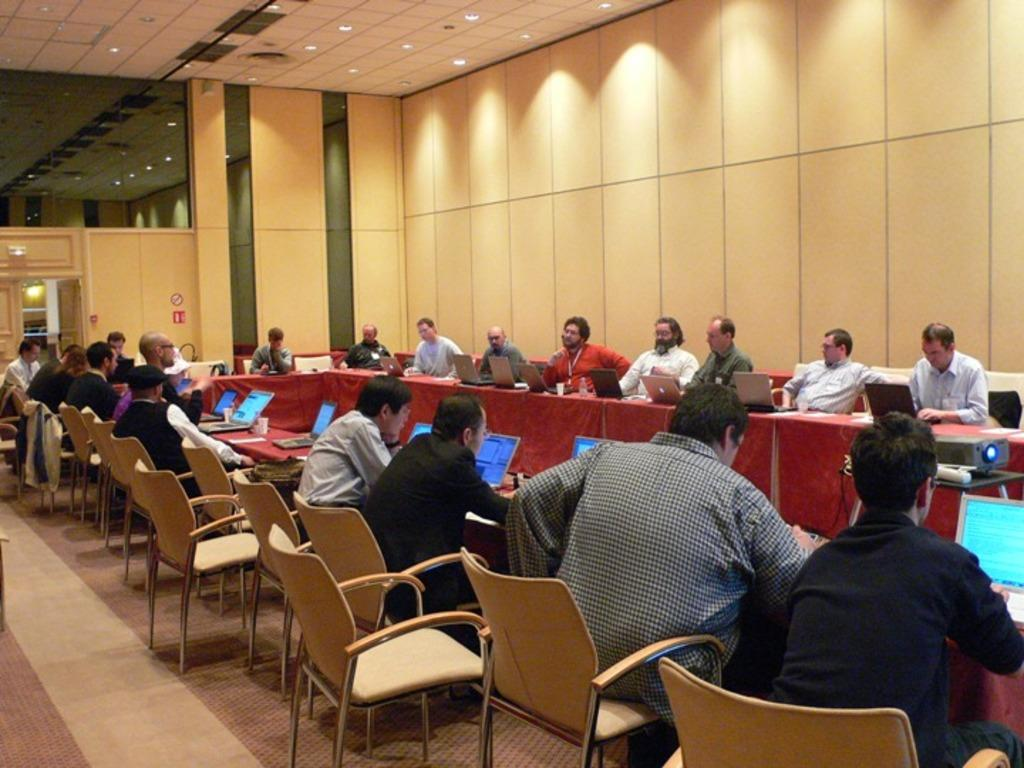Who is present in the image? There are people in the image. What are the people doing in the image? The people are sitting around a table and operating laptops. Where is the scene taking place? The setting is in a room. What is the rate of the people's sleep in the image? There is no information about the people's sleep in the image, as they are shown operating laptops while sitting around a table. 